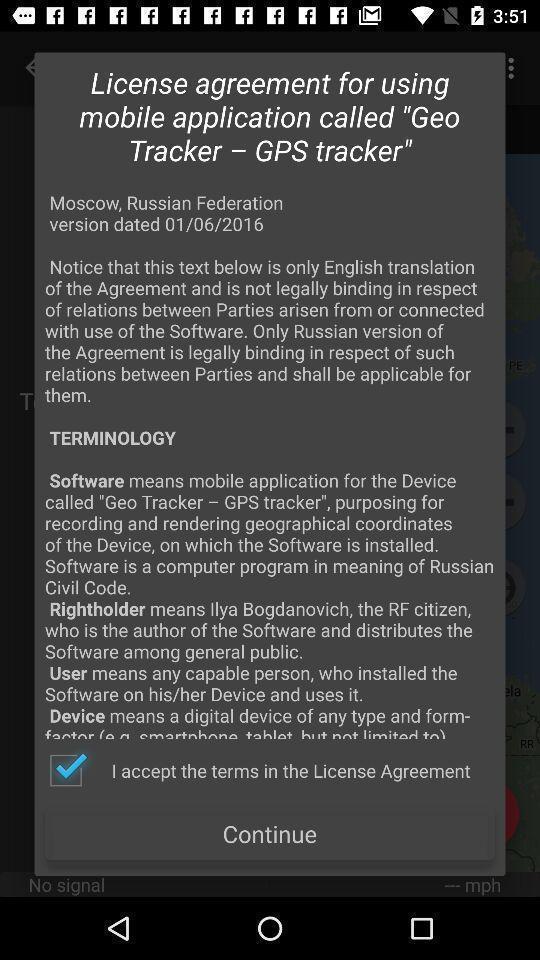Describe the visual elements of this screenshot. Pop-up showing licence agreement information with continue option. 